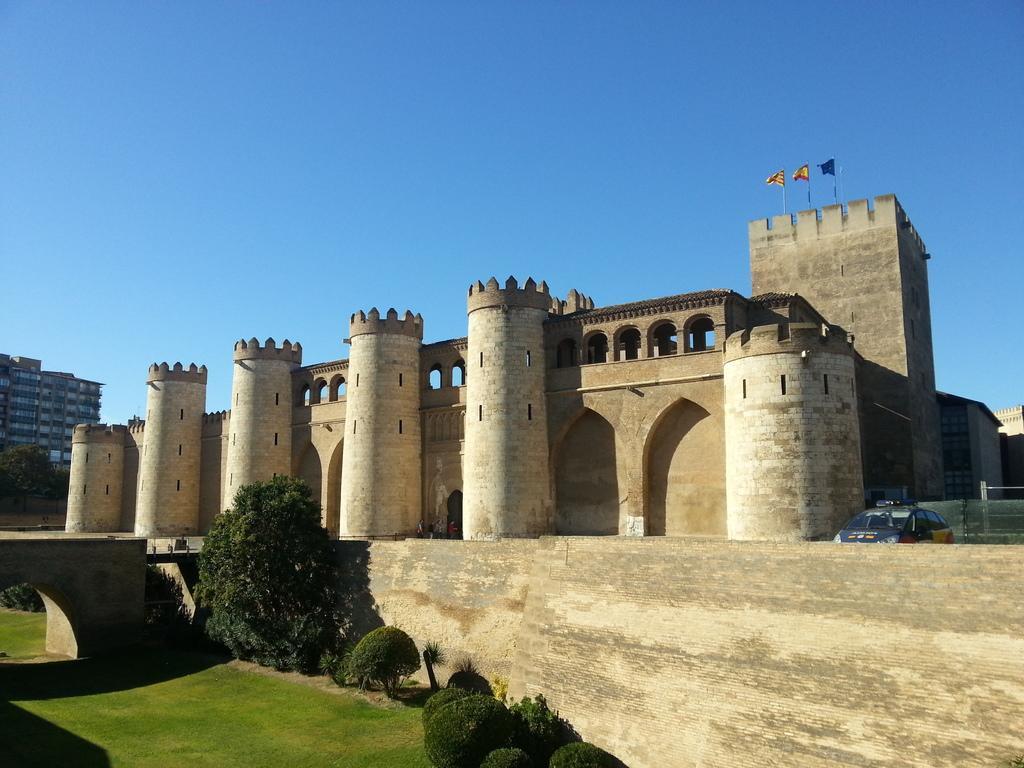How would you summarize this image in a sentence or two? There is a fort, there are three flags flying above the fort and on the right side there is a car, in front of the fort there is a garden with different plants and trees. Behind the fort there's a big building. 